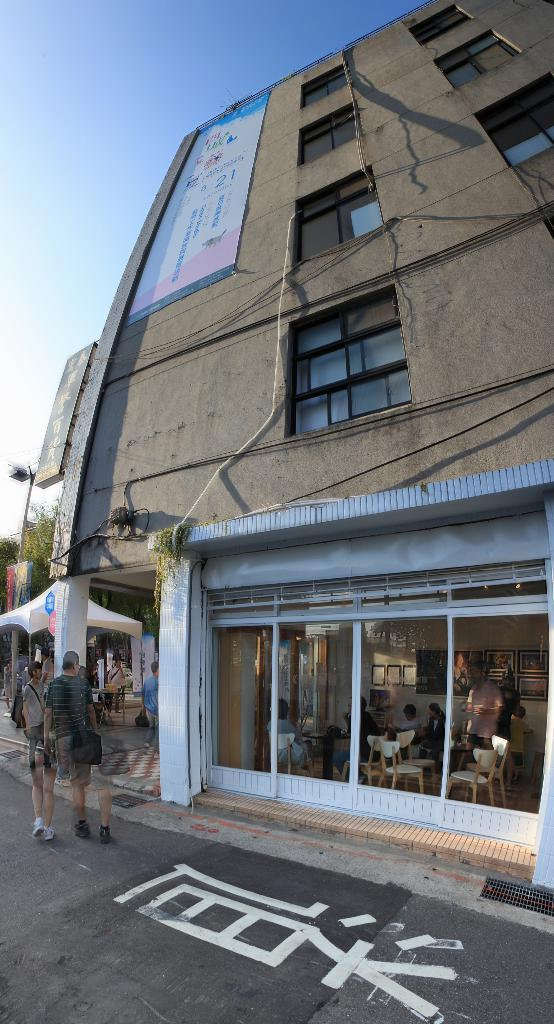What structure is present in the image? There is a building in the image. What is attached to the building? There is a banner on the building. What can be seen on the left side of the image? There are two persons walking on the left side of the image. What is visible at the top of the image? The sky is visible at the top of the image. What type of feet can be seen on the banner in the image? There are no feet present on the banner in the image. What answer is provided by the building in the image? The building in the image does not provide an answer to any question. 